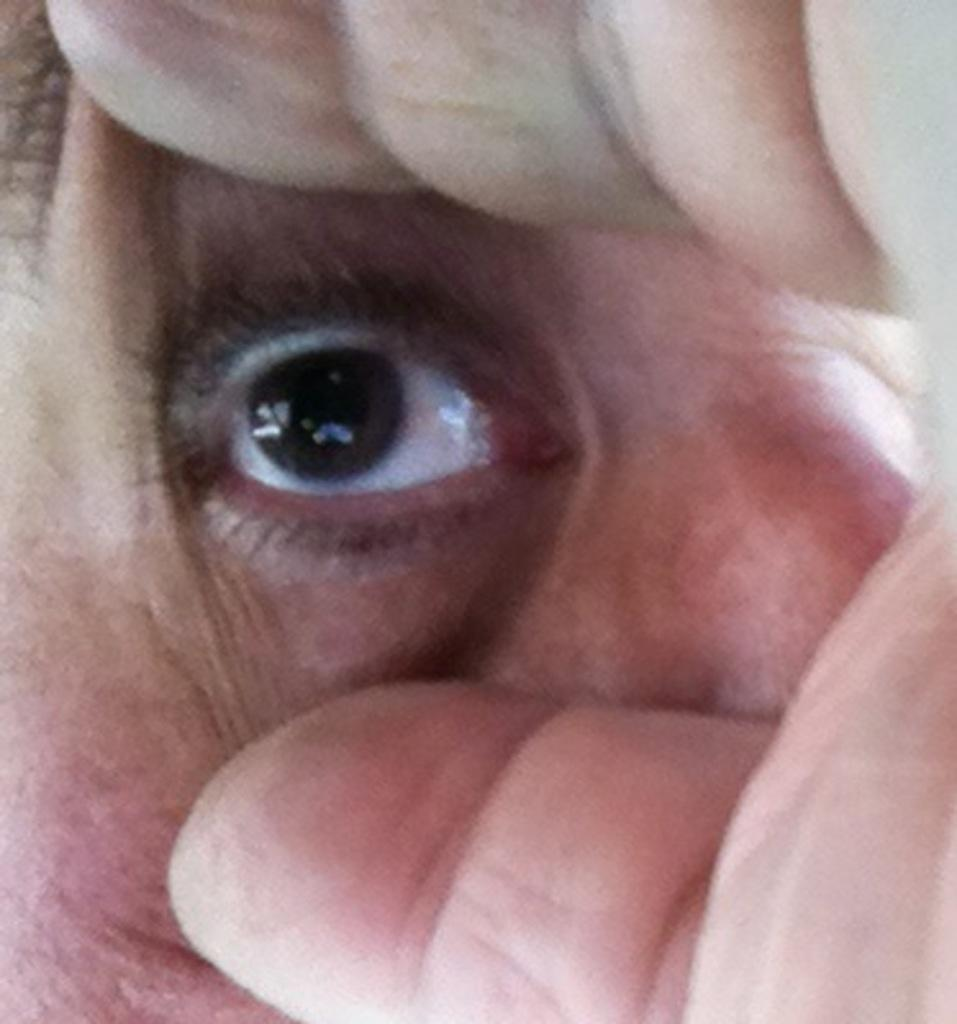What is happening in the image? There is a person in the image, and they are trying to open their eye. How is the person attempting to open their eye? The person is using their hand to help open their eye. What type of regret can be seen on the person's face in the image? There is no indication of regret on the person's face in the image; they are simply trying to open their eye. 